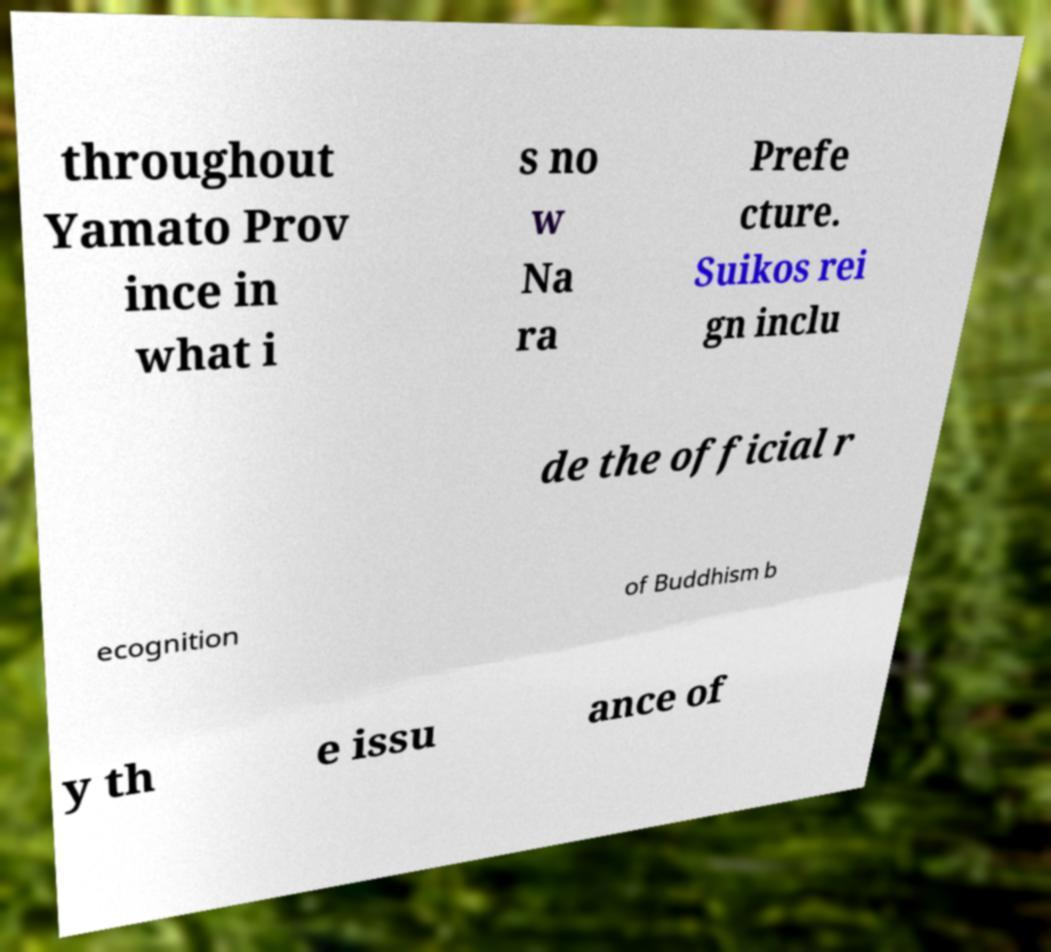For documentation purposes, I need the text within this image transcribed. Could you provide that? throughout Yamato Prov ince in what i s no w Na ra Prefe cture. Suikos rei gn inclu de the official r ecognition of Buddhism b y th e issu ance of 